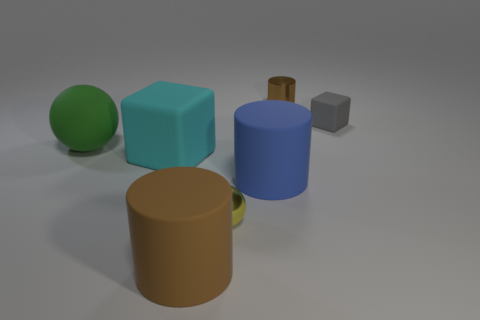How many large objects are both in front of the large block and left of the yellow ball?
Your answer should be very brief. 1. The tiny sphere is what color?
Keep it short and to the point. Yellow. Is there a big blue thing made of the same material as the large sphere?
Your answer should be compact. Yes. Are there any tiny brown cylinders left of the tiny metal object that is behind the cyan matte thing in front of the large rubber ball?
Your response must be concise. No. There is a large blue thing; are there any large rubber objects to the left of it?
Your answer should be compact. Yes. Is there a large ball of the same color as the small cube?
Your answer should be compact. No. What number of small objects are either brown rubber things or cubes?
Your answer should be compact. 1. Are the cube on the left side of the brown rubber thing and the tiny brown cylinder made of the same material?
Your answer should be compact. No. There is a brown thing that is in front of the brown cylinder that is to the right of the metal thing in front of the green rubber thing; what is its shape?
Give a very brief answer. Cylinder. What number of gray things are large objects or small metal objects?
Offer a very short reply. 0. 